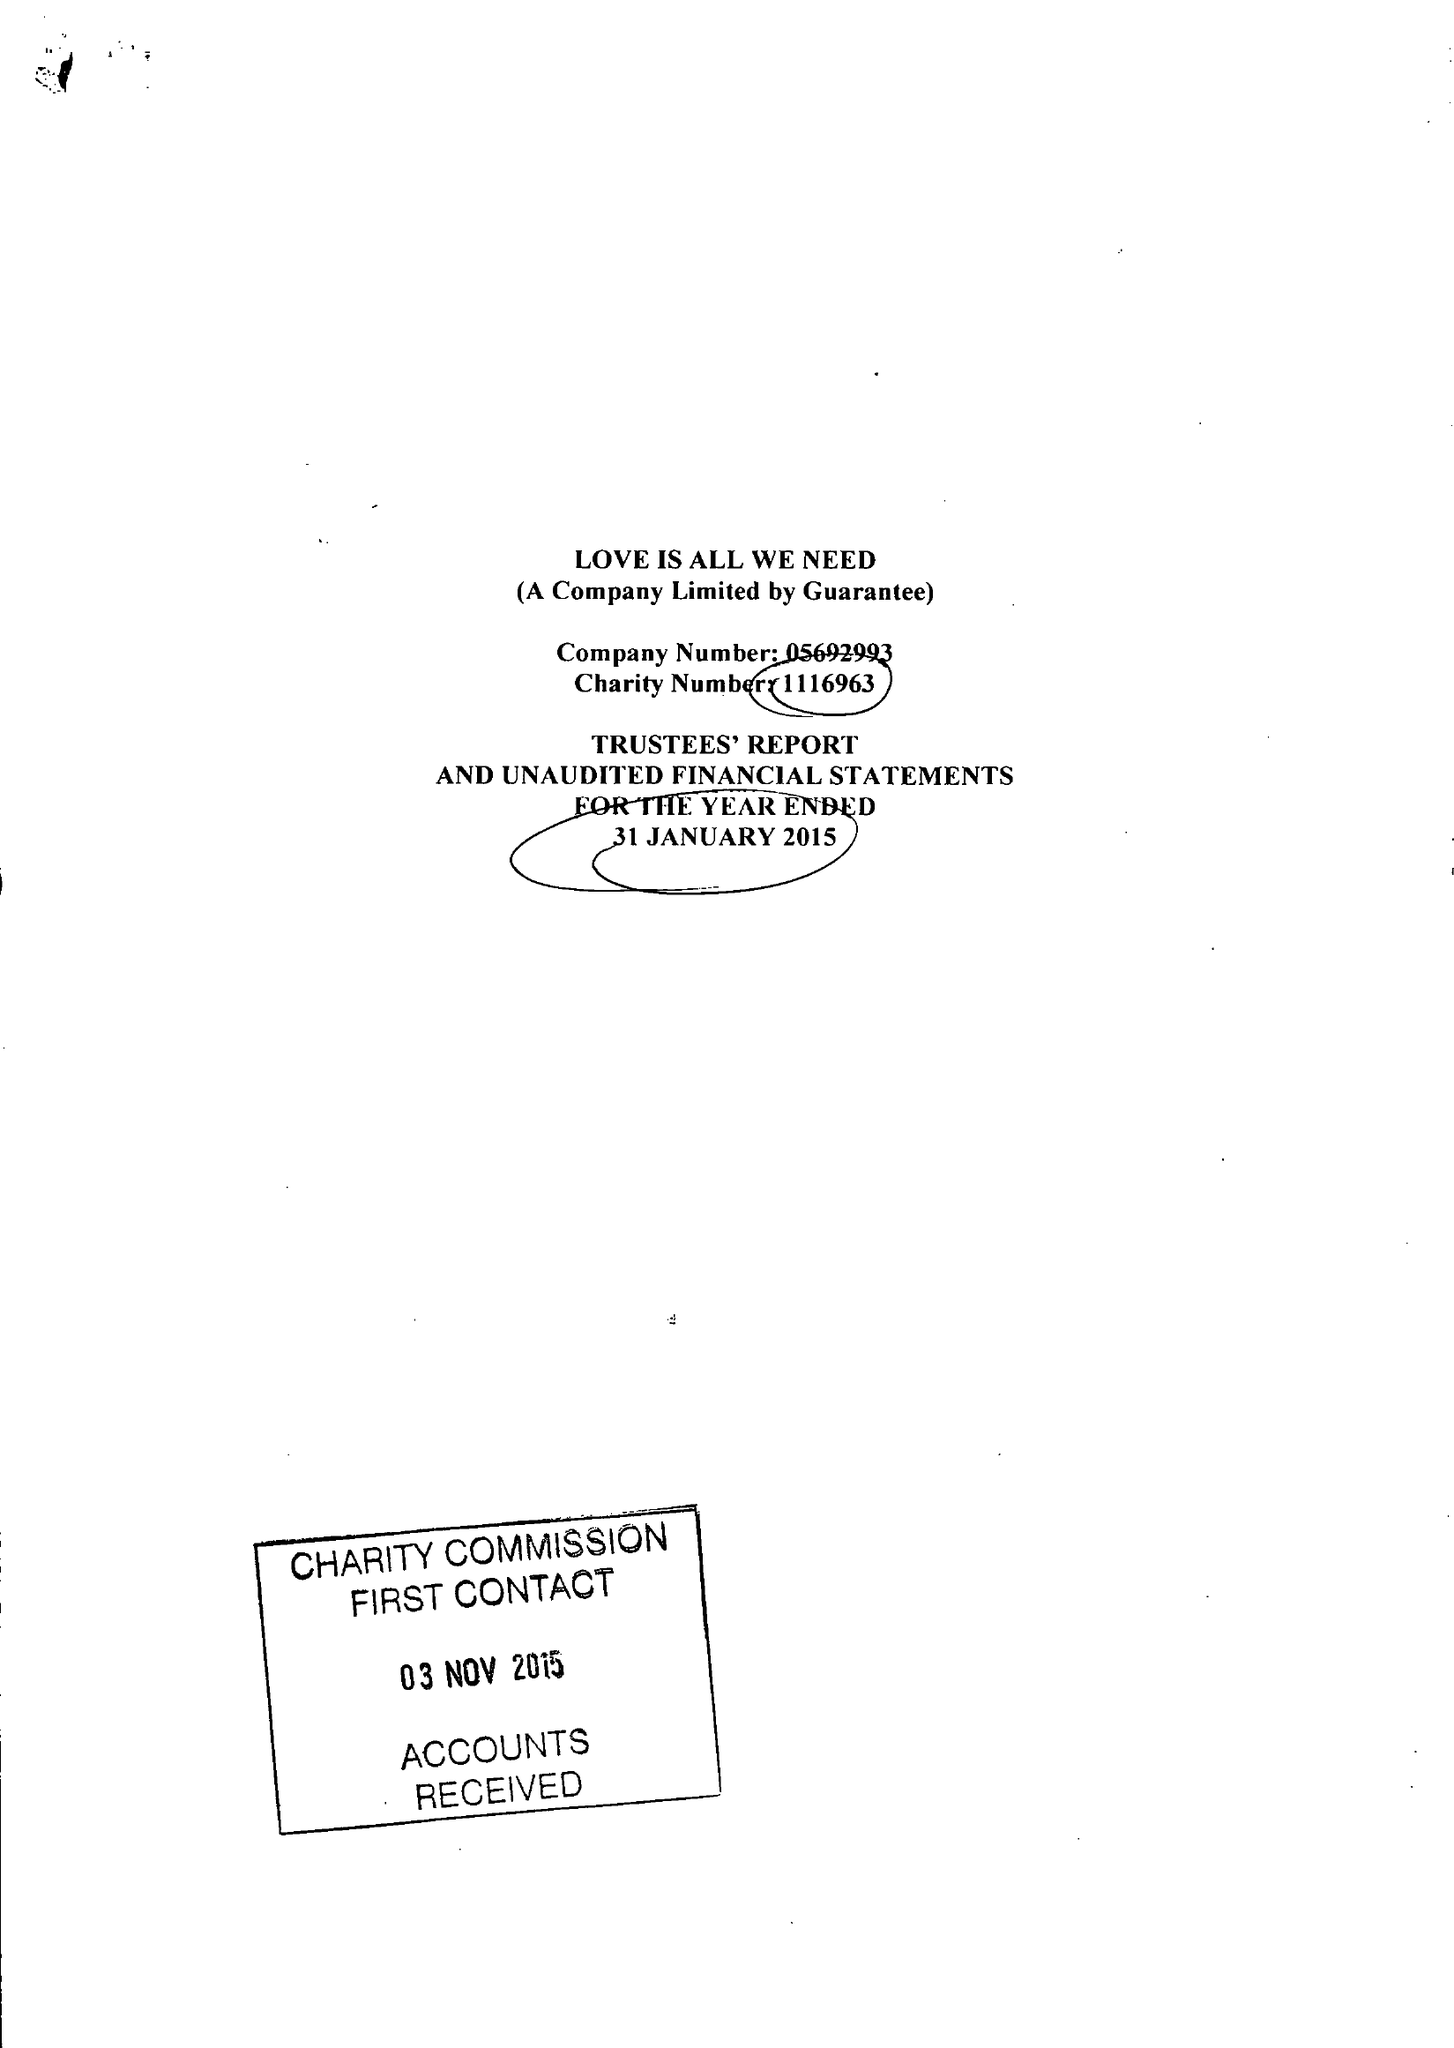What is the value for the income_annually_in_british_pounds?
Answer the question using a single word or phrase. 66361.00 